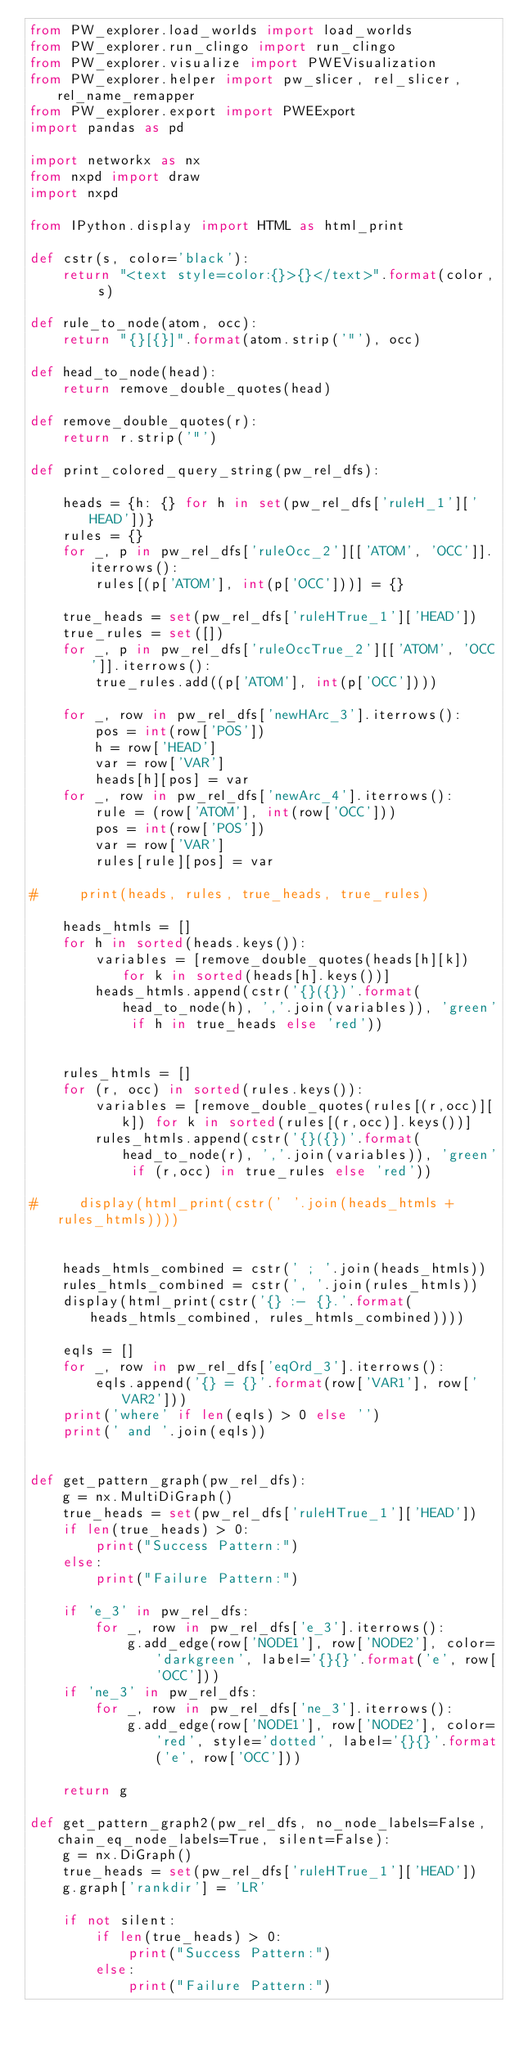<code> <loc_0><loc_0><loc_500><loc_500><_Python_>from PW_explorer.load_worlds import load_worlds
from PW_explorer.run_clingo import run_clingo
from PW_explorer.visualize import PWEVisualization
from PW_explorer.helper import pw_slicer, rel_slicer, rel_name_remapper
from PW_explorer.export import PWEExport
import pandas as pd

import networkx as nx
from nxpd import draw
import nxpd

from IPython.display import HTML as html_print

def cstr(s, color='black'):
    return "<text style=color:{}>{}</text>".format(color, s)

def rule_to_node(atom, occ):
    return "{}[{}]".format(atom.strip('"'), occ)

def head_to_node(head):
    return remove_double_quotes(head)

def remove_double_quotes(r):
    return r.strip('"')

def print_colored_query_string(pw_rel_dfs):
    
    heads = {h: {} for h in set(pw_rel_dfs['ruleH_1']['HEAD'])}
    rules = {}
    for _, p in pw_rel_dfs['ruleOcc_2'][['ATOM', 'OCC']].iterrows():
        rules[(p['ATOM'], int(p['OCC']))] = {}
    
    true_heads = set(pw_rel_dfs['ruleHTrue_1']['HEAD'])
    true_rules = set([])
    for _, p in pw_rel_dfs['ruleOccTrue_2'][['ATOM', 'OCC']].iterrows():
        true_rules.add((p['ATOM'], int(p['OCC'])))
    
    for _, row in pw_rel_dfs['newHArc_3'].iterrows():
        pos = int(row['POS'])
        h = row['HEAD']
        var = row['VAR']
        heads[h][pos] = var
    for _, row in pw_rel_dfs['newArc_4'].iterrows():
        rule = (row['ATOM'], int(row['OCC']))
        pos = int(row['POS'])
        var = row['VAR']
        rules[rule][pos] = var
        
#     print(heads, rules, true_heads, true_rules)
    
    heads_htmls = []
    for h in sorted(heads.keys()):
        variables = [remove_double_quotes(heads[h][k]) for k in sorted(heads[h].keys())]
        heads_htmls.append(cstr('{}({})'.format(head_to_node(h), ','.join(variables)), 'green' if h in true_heads else 'red'))
    
    
    rules_htmls = []
    for (r, occ) in sorted(rules.keys()):
        variables = [remove_double_quotes(rules[(r,occ)][k]) for k in sorted(rules[(r,occ)].keys())]
        rules_htmls.append(cstr('{}({})'.format(head_to_node(r), ','.join(variables)), 'green' if (r,occ) in true_rules else 'red'))
    
#     display(html_print(cstr(' '.join(heads_htmls + rules_htmls))))
    
    
    heads_htmls_combined = cstr(' ; '.join(heads_htmls))
    rules_htmls_combined = cstr(', '.join(rules_htmls))
    display(html_print(cstr('{} :- {}.'.format(heads_htmls_combined, rules_htmls_combined))))
    
    eqls = []
    for _, row in pw_rel_dfs['eqOrd_3'].iterrows():
        eqls.append('{} = {}'.format(row['VAR1'], row['VAR2']))
    print('where' if len(eqls) > 0 else '')
    print(' and '.join(eqls))
    
    
def get_pattern_graph(pw_rel_dfs):
    g = nx.MultiDiGraph()
    true_heads = set(pw_rel_dfs['ruleHTrue_1']['HEAD'])
    if len(true_heads) > 0:
        print("Success Pattern:")
    else:
        print("Failure Pattern:")
    
    if 'e_3' in pw_rel_dfs:
        for _, row in pw_rel_dfs['e_3'].iterrows():
            g.add_edge(row['NODE1'], row['NODE2'], color='darkgreen', label='{}{}'.format('e', row['OCC']))
    if 'ne_3' in pw_rel_dfs:
        for _, row in pw_rel_dfs['ne_3'].iterrows():
            g.add_edge(row['NODE1'], row['NODE2'], color='red', style='dotted', label='{}{}'.format('e', row['OCC']))
    
    return g

def get_pattern_graph2(pw_rel_dfs, no_node_labels=False, chain_eq_node_labels=True, silent=False):
    g = nx.DiGraph()
    true_heads = set(pw_rel_dfs['ruleHTrue_1']['HEAD'])
    g.graph['rankdir'] = 'LR'
    
    if not silent:
        if len(true_heads) > 0:
            print("Success Pattern:")
        else:
            print("Failure Pattern:")
    </code> 